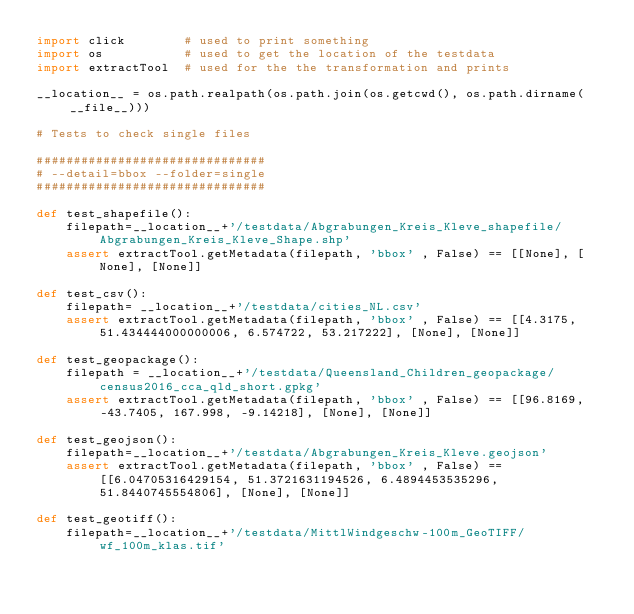<code> <loc_0><loc_0><loc_500><loc_500><_Python_>import click        # used to print something
import os           # used to get the location of the testdata
import extractTool  # used for the the transformation and prints  

__location__ = os.path.realpath(os.path.join(os.getcwd(), os.path.dirname(__file__)))

# Tests to check single files

###############################
# --detail=bbox --folder=single
###############################

def test_shapefile():
    filepath=__location__+'/testdata/Abgrabungen_Kreis_Kleve_shapefile/Abgrabungen_Kreis_Kleve_Shape.shp'
    assert extractTool.getMetadata(filepath, 'bbox' , False) == [[None], [None], [None]]

def test_csv():  
    filepath= __location__+'/testdata/cities_NL.csv'
    assert extractTool.getMetadata(filepath, 'bbox' , False) == [[4.3175, 51.434444000000006, 6.574722, 53.217222], [None], [None]]

def test_geopackage():
    filepath = __location__+'/testdata/Queensland_Children_geopackage/census2016_cca_qld_short.gpkg'    
    assert extractTool.getMetadata(filepath, 'bbox' , False) == [[96.8169, -43.7405, 167.998, -9.14218], [None], [None]]

def test_geojson():
    filepath=__location__+'/testdata/Abgrabungen_Kreis_Kleve.geojson'
    assert extractTool.getMetadata(filepath, 'bbox' , False) == [[6.04705316429154, 51.3721631194526, 6.4894453535296, 51.8440745554806], [None], [None]]

def test_geotiff():
    filepath=__location__+'/testdata/MittlWindgeschw-100m_GeoTIFF/wf_100m_klas.tif'</code> 